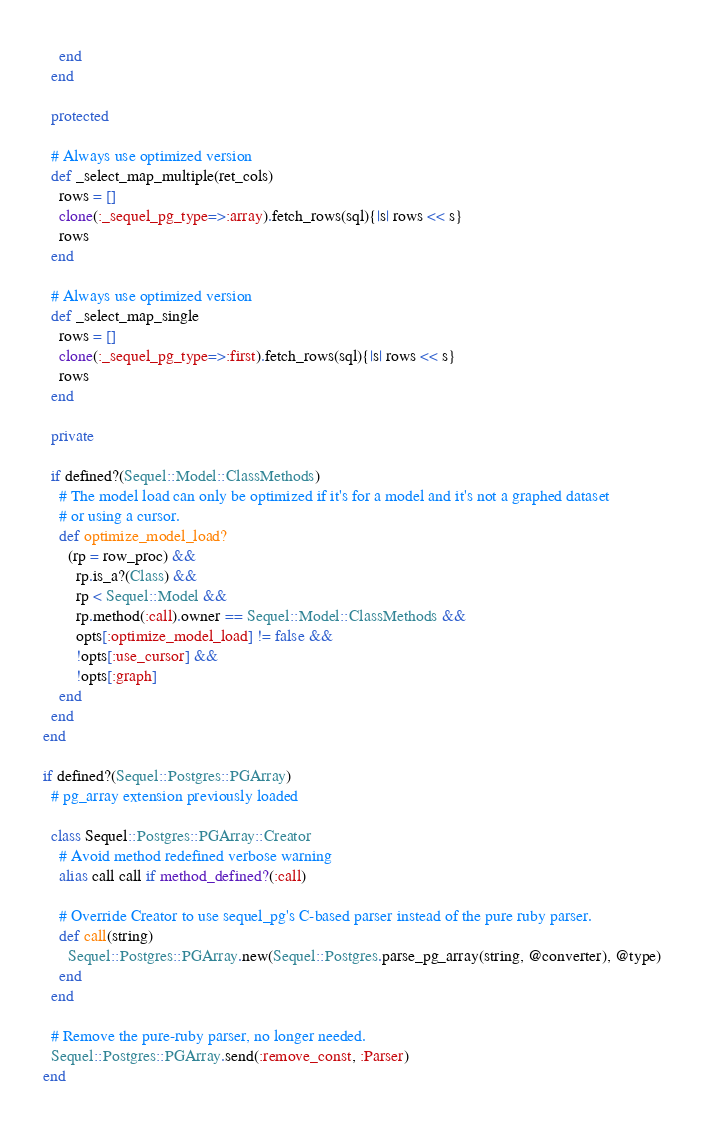Convert code to text. <code><loc_0><loc_0><loc_500><loc_500><_Ruby_>    end
  end
    
  protected

  # Always use optimized version
  def _select_map_multiple(ret_cols)
    rows = []
    clone(:_sequel_pg_type=>:array).fetch_rows(sql){|s| rows << s}
    rows
  end

  # Always use optimized version
  def _select_map_single
    rows = []
    clone(:_sequel_pg_type=>:first).fetch_rows(sql){|s| rows << s}
    rows
  end

  private

  if defined?(Sequel::Model::ClassMethods)
    # The model load can only be optimized if it's for a model and it's not a graphed dataset
    # or using a cursor.
    def optimize_model_load?
      (rp = row_proc) &&
        rp.is_a?(Class) &&
        rp < Sequel::Model &&
        rp.method(:call).owner == Sequel::Model::ClassMethods &&
        opts[:optimize_model_load] != false &&
        !opts[:use_cursor] &&
        !opts[:graph]
    end
  end
end

if defined?(Sequel::Postgres::PGArray)
  # pg_array extension previously loaded

  class Sequel::Postgres::PGArray::Creator
    # Avoid method redefined verbose warning
    alias call call if method_defined?(:call)

    # Override Creator to use sequel_pg's C-based parser instead of the pure ruby parser.
    def call(string)
      Sequel::Postgres::PGArray.new(Sequel::Postgres.parse_pg_array(string, @converter), @type)
    end
  end

  # Remove the pure-ruby parser, no longer needed.
  Sequel::Postgres::PGArray.send(:remove_const, :Parser)
end
</code> 